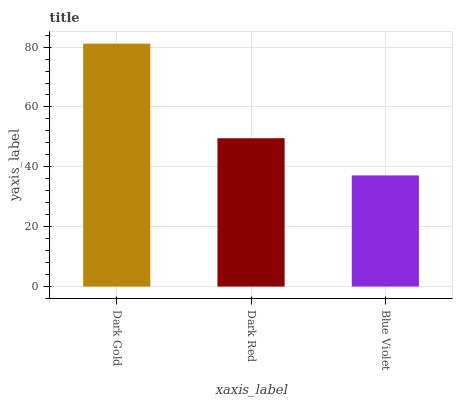Is Blue Violet the minimum?
Answer yes or no. Yes. Is Dark Gold the maximum?
Answer yes or no. Yes. Is Dark Red the minimum?
Answer yes or no. No. Is Dark Red the maximum?
Answer yes or no. No. Is Dark Gold greater than Dark Red?
Answer yes or no. Yes. Is Dark Red less than Dark Gold?
Answer yes or no. Yes. Is Dark Red greater than Dark Gold?
Answer yes or no. No. Is Dark Gold less than Dark Red?
Answer yes or no. No. Is Dark Red the high median?
Answer yes or no. Yes. Is Dark Red the low median?
Answer yes or no. Yes. Is Blue Violet the high median?
Answer yes or no. No. Is Dark Gold the low median?
Answer yes or no. No. 